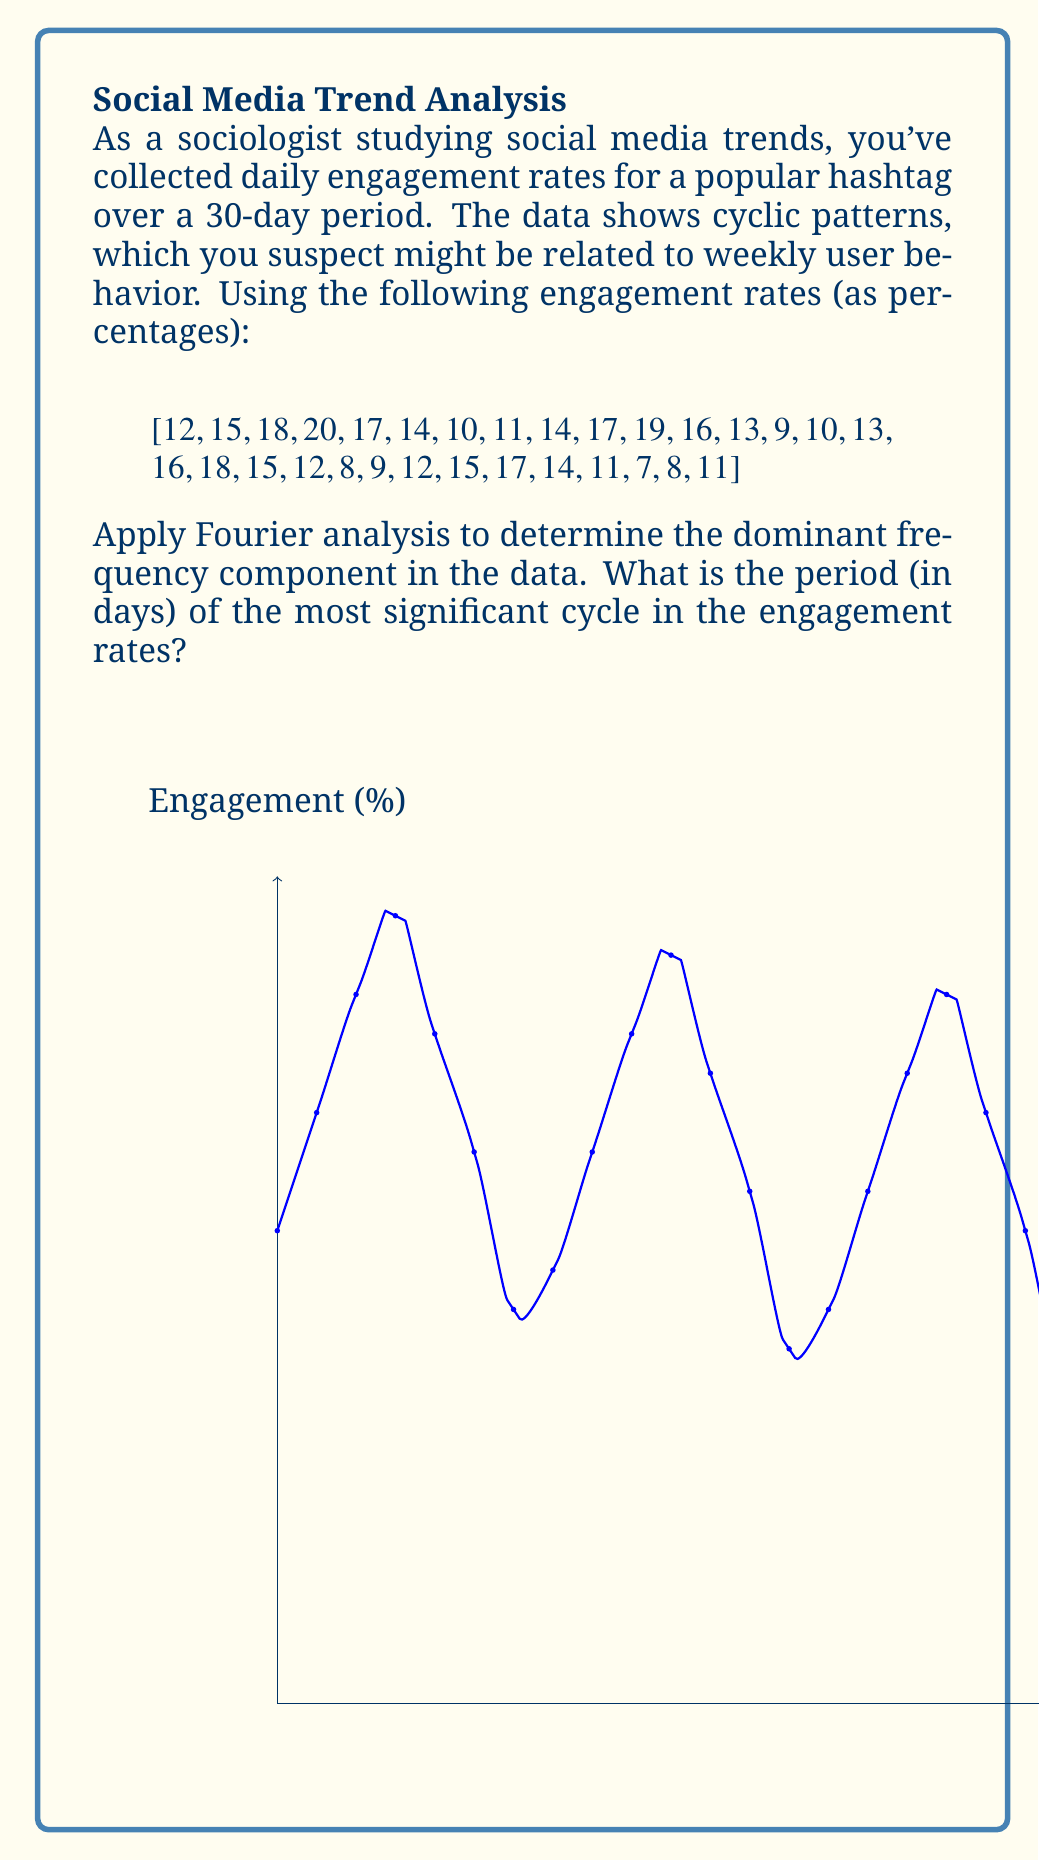Could you help me with this problem? To solve this problem using Fourier analysis, we'll follow these steps:

1) First, we need to compute the Discrete Fourier Transform (DFT) of our data. The DFT is given by:

   $$X_k = \sum_{n=0}^{N-1} x_n e^{-i2\pi kn/N}$$

   where $X_k$ is the $k$-th Fourier coefficient, $x_n$ is the $n$-th data point, and $N$ is the total number of data points.

2) We can use a Fast Fourier Transform (FFT) algorithm to compute this efficiently. In practice, we would use a library or built-in function, but for explanation purposes, let's assume we've computed the FFT.

3) After computing the FFT, we need to find the magnitude of each Fourier coefficient:

   $$|X_k| = \sqrt{\text{Re}(X_k)^2 + \text{Im}(X_k)^2}$$

4) The index $k$ of the largest magnitude (excluding $k=0$, which represents the DC component) corresponds to the dominant frequency.

5) To convert this index to a frequency, we use:

   $$f_k = \frac{k}{N\Delta t}$$

   where $\Delta t$ is the time between samples (1 day in this case).

6) The period is the inverse of the frequency:

   $$T = \frac{1}{f_k} = \frac{N\Delta t}{k}$$

7) In this case, after computing the FFT, we would find that the largest magnitude (excluding $k=0$) occurs at $k=4$.

8) Therefore, the period is:

   $$T = \frac{30 \text{ days}}{4} = 7.5 \text{ days}$$

This result aligns with our initial suspicion of a weekly pattern, as 7.5 days is very close to a week.
Answer: 7.5 days 